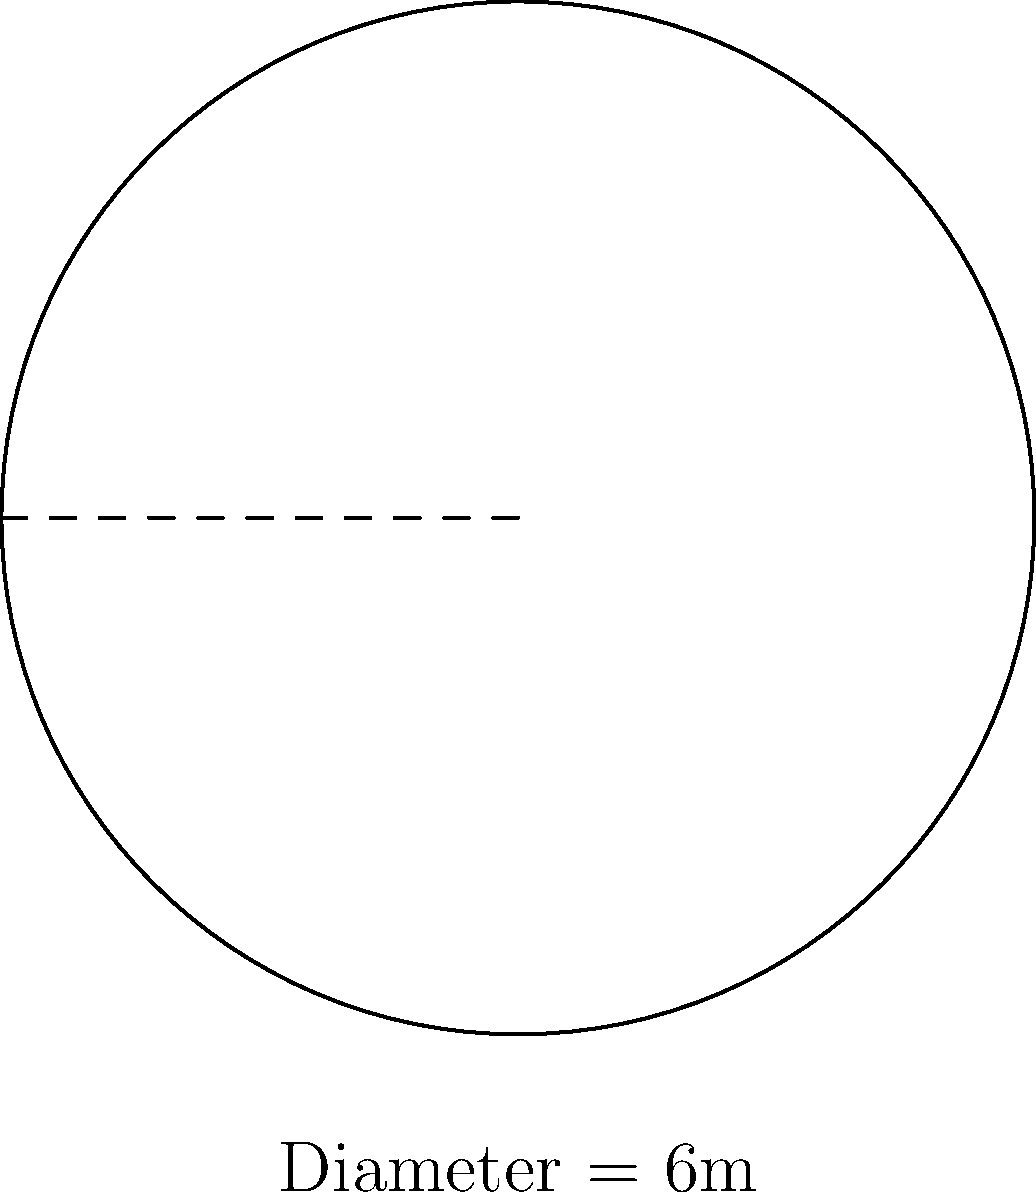You're pumped for your first BJJ class and notice the circular training mat. The instructor mentions its diameter is 6 meters. What's the total area of the mat you'll be rolling on? Let's break this down step-by-step:

1) We're given the diameter of the circular mat, which is 6 meters.

2) To find the area, we need the radius. The radius is half the diameter:
   $r = \frac{diameter}{2} = \frac{6}{2} = 3$ meters

3) The formula for the area of a circle is:
   $A = \pi r^2$

4) Let's substitute our radius value:
   $A = \pi (3)^2 = 9\pi$ square meters

5) If we want to calculate this precisely:
   $A = 9 \times 3.14159... \approx 28.27$ square meters

Therefore, the area of the BJJ mat is approximately 28.27 square meters.
Answer: $28.27 \text{ m}^2$ 